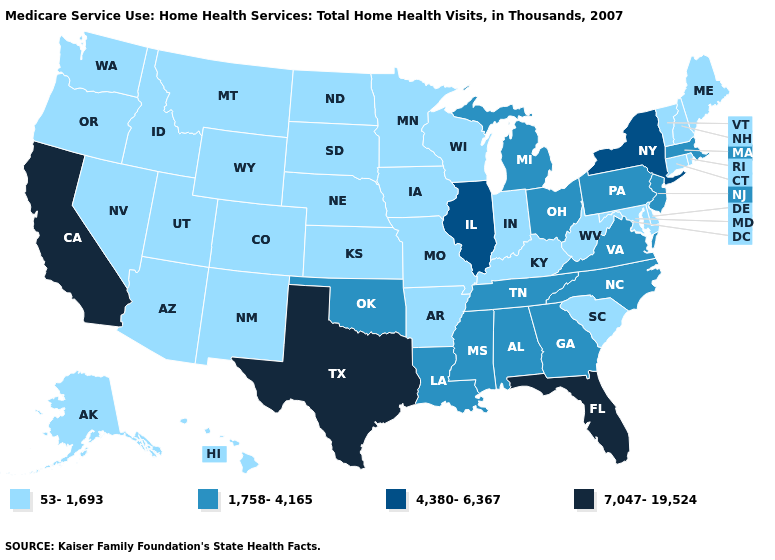What is the value of Alabama?
Concise answer only. 1,758-4,165. Does Kansas have the same value as Georgia?
Write a very short answer. No. Which states have the highest value in the USA?
Give a very brief answer. California, Florida, Texas. Which states have the highest value in the USA?
Write a very short answer. California, Florida, Texas. Name the states that have a value in the range 4,380-6,367?
Quick response, please. Illinois, New York. What is the highest value in states that border South Dakota?
Keep it brief. 53-1,693. Name the states that have a value in the range 7,047-19,524?
Write a very short answer. California, Florida, Texas. Among the states that border Indiana , which have the highest value?
Answer briefly. Illinois. What is the lowest value in the USA?
Write a very short answer. 53-1,693. Does the first symbol in the legend represent the smallest category?
Be succinct. Yes. What is the lowest value in states that border North Dakota?
Be succinct. 53-1,693. Among the states that border Illinois , which have the highest value?
Quick response, please. Indiana, Iowa, Kentucky, Missouri, Wisconsin. What is the highest value in the South ?
Be succinct. 7,047-19,524. What is the value of Idaho?
Quick response, please. 53-1,693. 